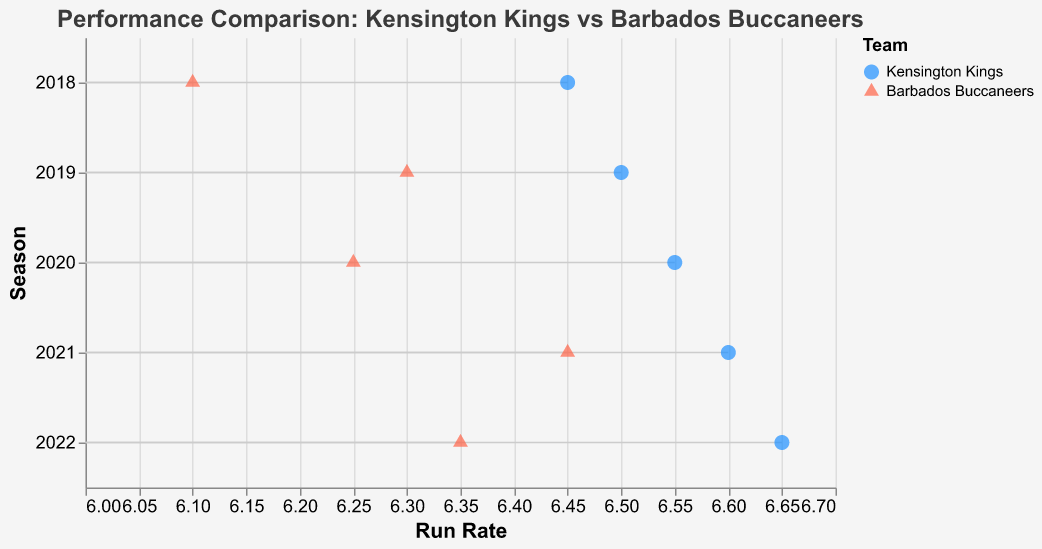Which team had the higher run rate in the 2018 season? In the 2018 season, the run rate for Kensington Kings was 6.45, while for Barbados Buccaneers it was 6.10. Therefore, Kensington Kings had the higher run rate.
Answer: Kensington Kings How many seasons are represented in the plot? By looking at the y-axis labeled "Season," we can count the number of unique entries which are: 2018, 2019, 2020, 2021, and 2022. This indicates that five seasons are represented in the plot.
Answer: Five seasons What's the difference in run rate between the Kensington Kings and Barbados Buccaneers in the 2020 season? In the 2020 season, the run rate for Kensington Kings was 6.55 and for Barbados Buccaneers it was 6.25. The difference is calculated as 6.55 - 6.25.
Answer: 0.30 Which season had the smallest run rate difference between the two teams? Comparing the listed differences:
- 2018: 6.45 - 6.10 = 0.35
- 2019: 6.50 - 6.30 = 0.20
- 2020: 6.55 - 6.25 = 0.30
- 2021: 6.60 - 6.45 = 0.15
- 2022: 6.65 - 6.35 = 0.30
The smallest difference was 0.15 in the 2021 season.
Answer: 2021 How many matches did the Kensington Kings win in the 2019 season? By checking the figure for "Matches Won" in the 2019 season, Kensington Kings won 9 matches.
Answer: 9 matches Did Barbados Buccaneers ever have a higher run rate than Kensington Kings in any season? By observing the plot for each season, there is no instance where the run rate of Barbados Buccaneers is higher than that of Kensington Kings.
Answer: No What's the average run rate of Kensington Kings over the five seasons? Summing the run rates of Kensington Kings over the five seasons: 6.45 + 6.50 + 6.55 + 6.60 + 6.65 = 32.75. Dividing by 5 gives an average run rate of 32.75/5 = 6.55.
Answer: 6.55 In which season did Barbados Buccaneers win the most matches? The plot indicates that Barbados Buccaneers won 9 matches in the 2021 season, which is the highest number of matches won by them in any season.
Answer: 2021 Between 2019 and 2022, which team had an increasing trend in run rate? For Kensington Kings, the run rates are: 2019: 6.50, 2020: 6.55, 2021: 6.60, and 2022: 6.65. For Barbados Buccaneers, the run rates are: 2019: 6.30, 2020: 6.25, 2021: 6.45, and 2022: 6.35. Kensington Kings show a consistent increase in run rate.
Answer: Kensington Kings 